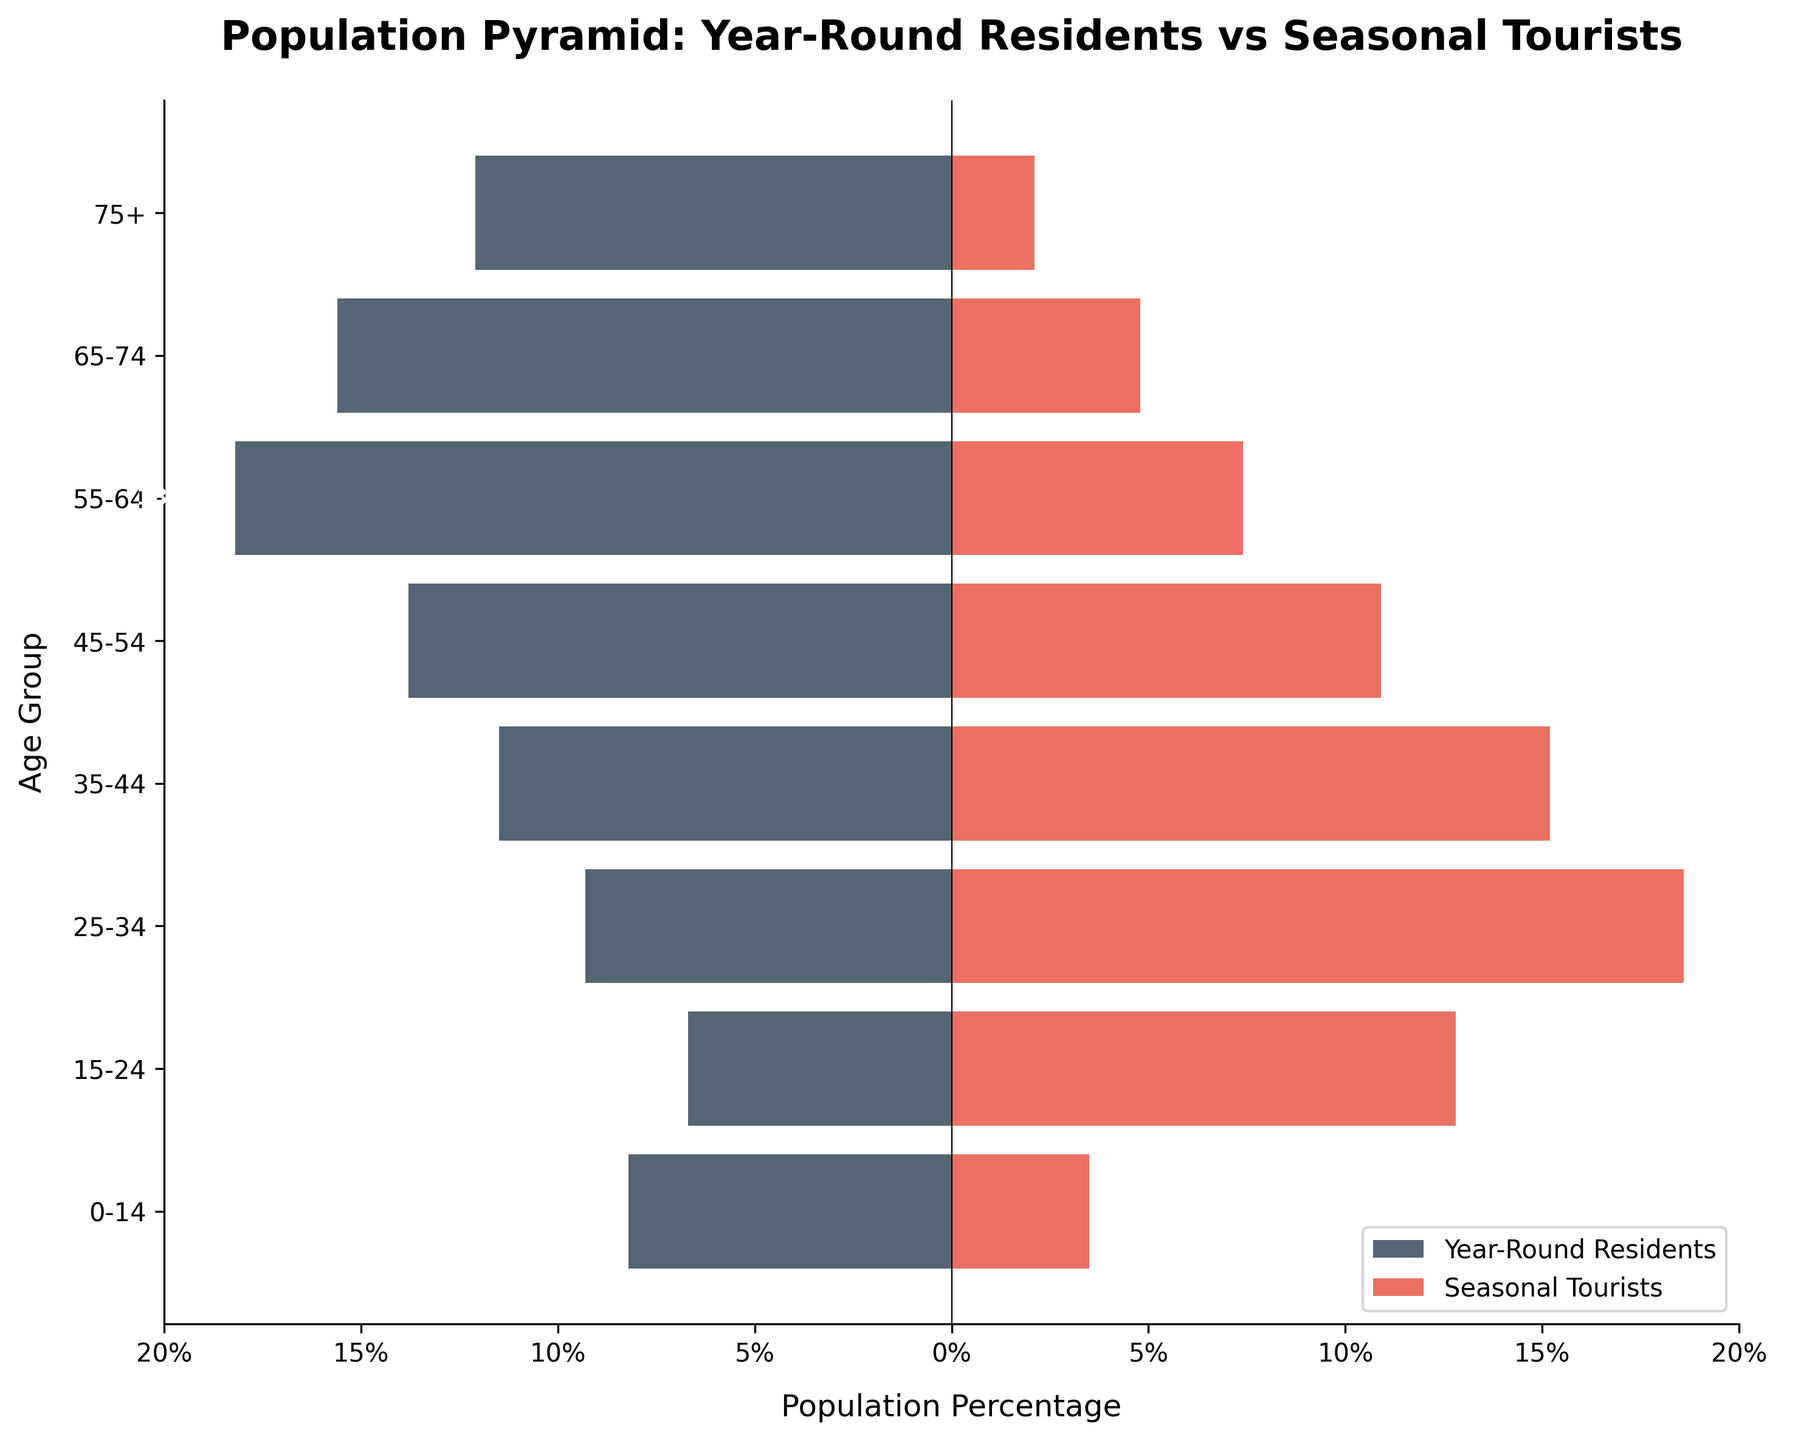What's the title of the plot? The title of the plot is located at the top center and clearly states the comparison being made
Answer: Population Pyramid: Year-Round Residents vs Seasonal Tourists What is the color used to represent 'Seasonal Tourists'? Observing the bars on the right side of the graph, we can see that 'Seasonal Tourists' are represented by a red color
Answer: Red Which age group has the highest percentage of Year-Round Residents? Looking at the chart, the age group with the largest negative bar indicates the highest percentage for Year-Round Residents
Answer: 55-64 What is the percentage of Seasonal Tourists in the 25-34 age group? Referring to the bar length for the 25-34 age group on the right-hand side, we find the percentage mentioned
Answer: 18.6% How do the percentages compare between Year-Round Residents and Seasonal Tourists in the 35-44 age group? Compare the lengths of the bars corresponding to the 35-44 age group for both Year-Round Residents and Seasonal Tourists
Answer: Year-Round Residents: -11.5%, Seasonal Tourists: 15.2% In which age group is the difference between Year-Round Residents and Seasonal Tourists the smallest? Calculate the absolute differences for each age group and identify the smallest value
Answer: 75+ (absolute difference of 14.2%) What is the total percentage of Year-Round Residents aged 0-34? Sum the percentages of Year-Round Residents for the age groups 0-14, 15-24, and 25-34
Answer: -8.2 + -6.7 + -9.3 = -24.2% Is there any age group where the percentage of Seasonal Tourists is less than the percentage of Year-Round Residents? Compare the bars of Year-Round Residents and Seasonal Tourists across all age groups to identify any instance where the value of Seasonal Tourists is lower
Answer: No, Seasonal Tourists always have a higher percentage Which age group has the largest disparity between Year-Round Residents and Seasonal Tourists? Calculate the absolute differences for each age group and find the largest value
Answer: 25-34 (difference of 27.9%) How many age groups have more than 10% Year-Round Residents? Count the number of age groups where the percentages of Year-Round Residents exceed -10%
Answer: 5 